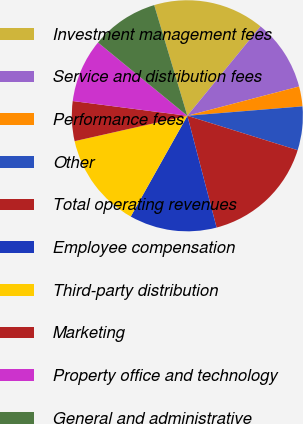<chart> <loc_0><loc_0><loc_500><loc_500><pie_chart><fcel>Investment management fees<fcel>Service and distribution fees<fcel>Performance fees<fcel>Other<fcel>Total operating revenues<fcel>Employee compensation<fcel>Third-party distribution<fcel>Marketing<fcel>Property office and technology<fcel>General and administrative<nl><fcel>15.55%<fcel>10.0%<fcel>2.78%<fcel>6.11%<fcel>16.11%<fcel>12.22%<fcel>13.33%<fcel>5.56%<fcel>8.89%<fcel>9.44%<nl></chart> 